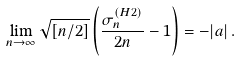<formula> <loc_0><loc_0><loc_500><loc_500>\lim _ { n \to \infty } \sqrt { [ n / 2 ] } \left ( \frac { \sigma _ { n } ^ { ( H 2 ) } } { 2 n } - 1 \right ) = - | a | \, .</formula> 